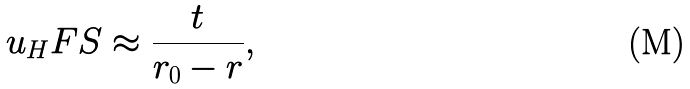<formula> <loc_0><loc_0><loc_500><loc_500>u _ { H } F S \approx \frac { t } { r _ { 0 } - r } ,</formula> 